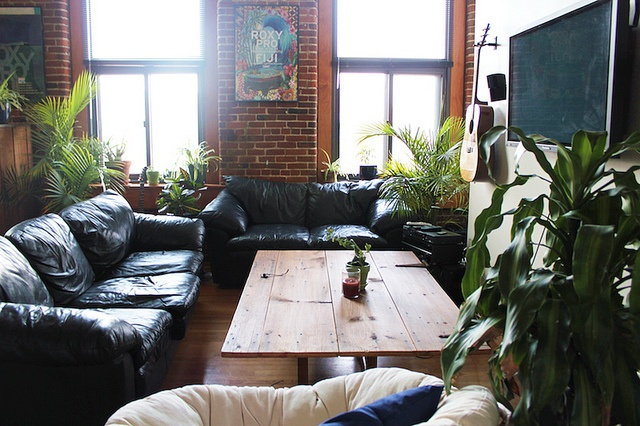Describe the objects in this image and their specific colors. I can see potted plant in black, lightgray, gray, and darkgreen tones, potted plant in black, lightgray, gray, and darkgreen tones, couch in black, white, and gray tones, tv in black, blue, darkblue, and gray tones, and couch in black, gray, and white tones in this image. 